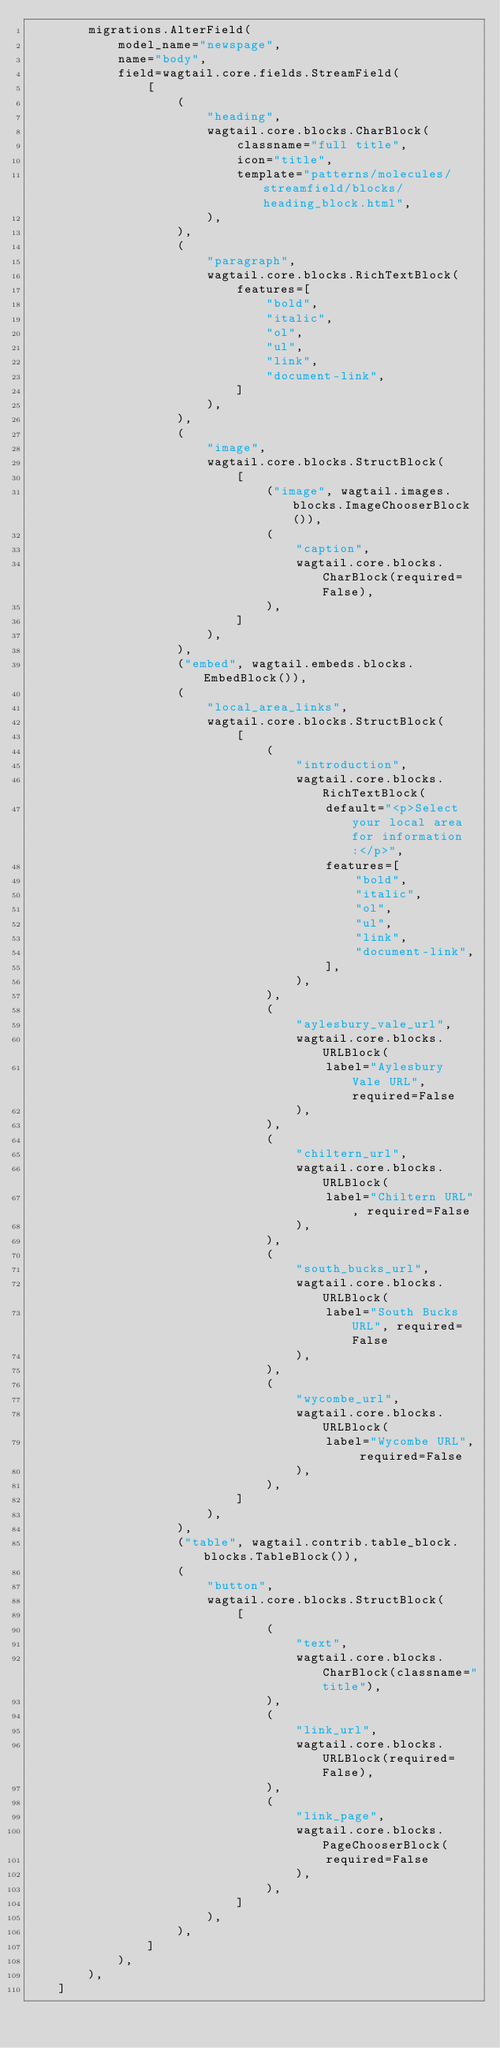Convert code to text. <code><loc_0><loc_0><loc_500><loc_500><_Python_>        migrations.AlterField(
            model_name="newspage",
            name="body",
            field=wagtail.core.fields.StreamField(
                [
                    (
                        "heading",
                        wagtail.core.blocks.CharBlock(
                            classname="full title",
                            icon="title",
                            template="patterns/molecules/streamfield/blocks/heading_block.html",
                        ),
                    ),
                    (
                        "paragraph",
                        wagtail.core.blocks.RichTextBlock(
                            features=[
                                "bold",
                                "italic",
                                "ol",
                                "ul",
                                "link",
                                "document-link",
                            ]
                        ),
                    ),
                    (
                        "image",
                        wagtail.core.blocks.StructBlock(
                            [
                                ("image", wagtail.images.blocks.ImageChooserBlock()),
                                (
                                    "caption",
                                    wagtail.core.blocks.CharBlock(required=False),
                                ),
                            ]
                        ),
                    ),
                    ("embed", wagtail.embeds.blocks.EmbedBlock()),
                    (
                        "local_area_links",
                        wagtail.core.blocks.StructBlock(
                            [
                                (
                                    "introduction",
                                    wagtail.core.blocks.RichTextBlock(
                                        default="<p>Select your local area for information:</p>",
                                        features=[
                                            "bold",
                                            "italic",
                                            "ol",
                                            "ul",
                                            "link",
                                            "document-link",
                                        ],
                                    ),
                                ),
                                (
                                    "aylesbury_vale_url",
                                    wagtail.core.blocks.URLBlock(
                                        label="Aylesbury Vale URL", required=False
                                    ),
                                ),
                                (
                                    "chiltern_url",
                                    wagtail.core.blocks.URLBlock(
                                        label="Chiltern URL", required=False
                                    ),
                                ),
                                (
                                    "south_bucks_url",
                                    wagtail.core.blocks.URLBlock(
                                        label="South Bucks URL", required=False
                                    ),
                                ),
                                (
                                    "wycombe_url",
                                    wagtail.core.blocks.URLBlock(
                                        label="Wycombe URL", required=False
                                    ),
                                ),
                            ]
                        ),
                    ),
                    ("table", wagtail.contrib.table_block.blocks.TableBlock()),
                    (
                        "button",
                        wagtail.core.blocks.StructBlock(
                            [
                                (
                                    "text",
                                    wagtail.core.blocks.CharBlock(classname="title"),
                                ),
                                (
                                    "link_url",
                                    wagtail.core.blocks.URLBlock(required=False),
                                ),
                                (
                                    "link_page",
                                    wagtail.core.blocks.PageChooserBlock(
                                        required=False
                                    ),
                                ),
                            ]
                        ),
                    ),
                ]
            ),
        ),
    ]
</code> 